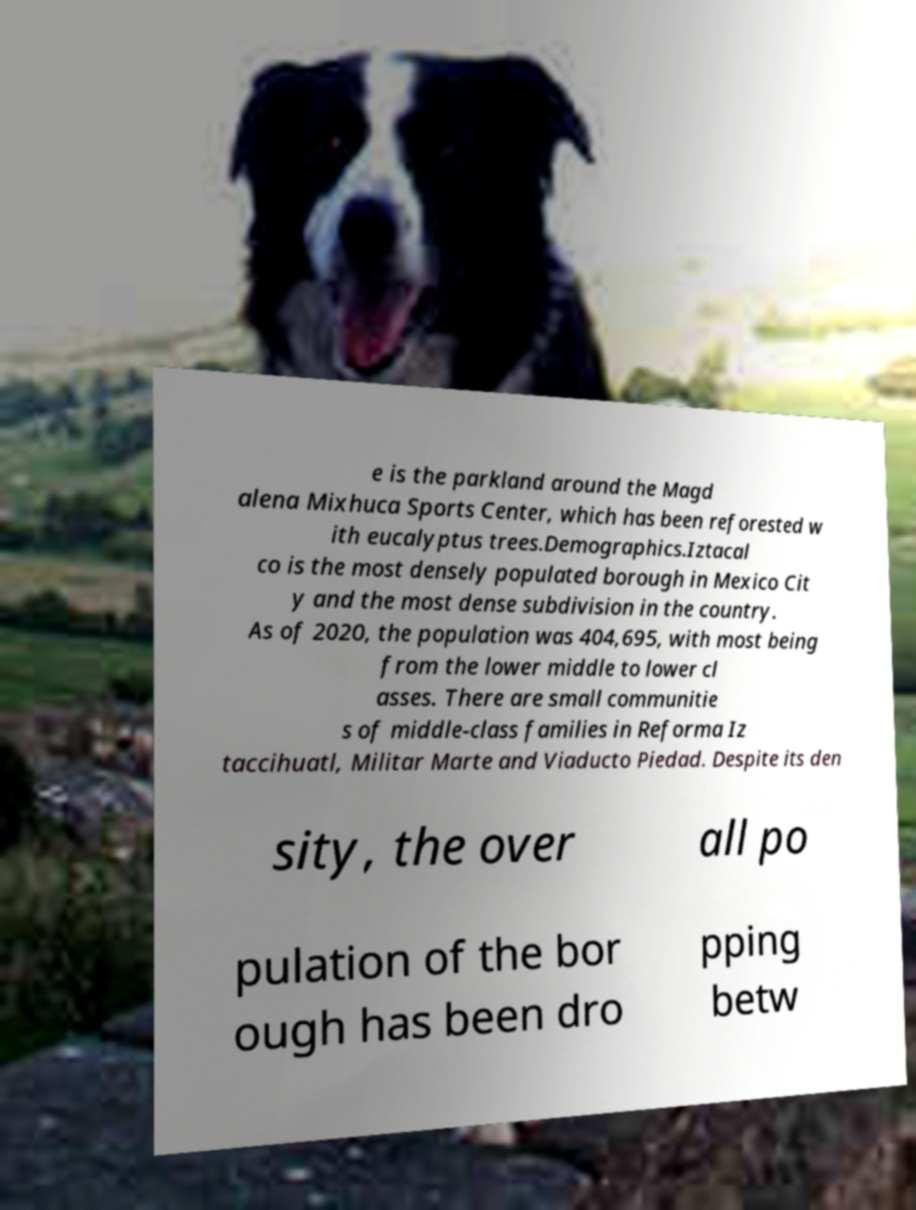Can you read and provide the text displayed in the image?This photo seems to have some interesting text. Can you extract and type it out for me? e is the parkland around the Magd alena Mixhuca Sports Center, which has been reforested w ith eucalyptus trees.Demographics.Iztacal co is the most densely populated borough in Mexico Cit y and the most dense subdivision in the country. As of 2020, the population was 404,695, with most being from the lower middle to lower cl asses. There are small communitie s of middle-class families in Reforma Iz taccihuatl, Militar Marte and Viaducto Piedad. Despite its den sity, the over all po pulation of the bor ough has been dro pping betw 